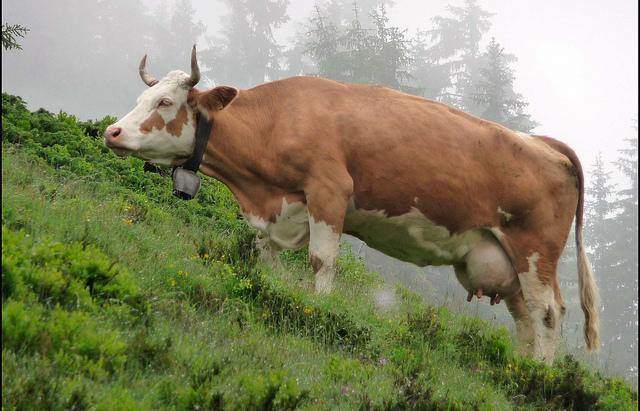How many cows are in the scene?
Give a very brief answer. 1. 